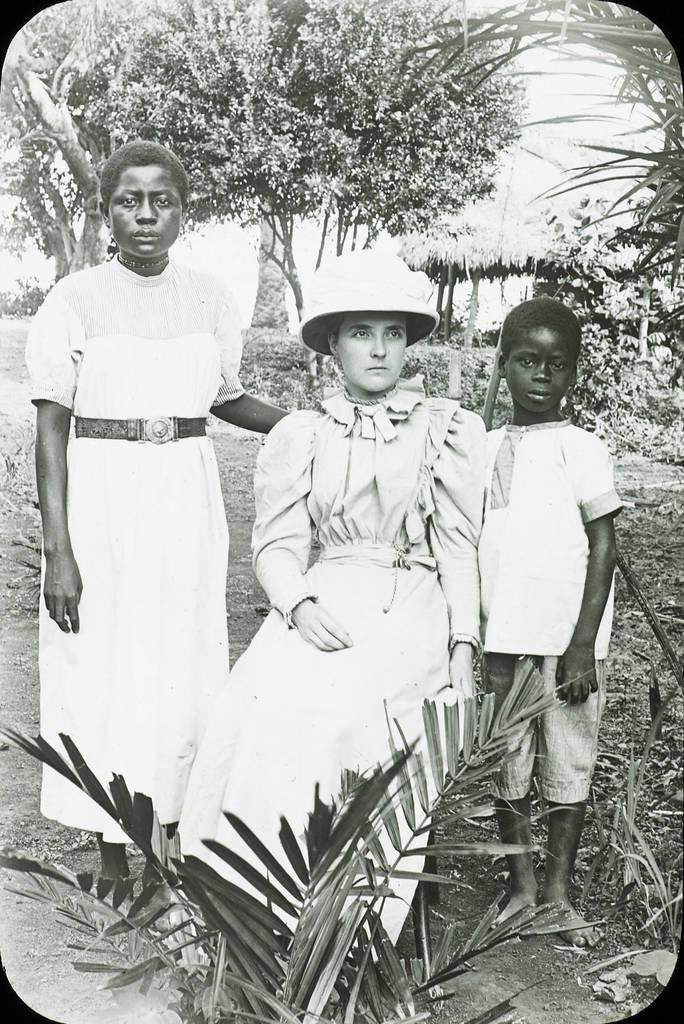How many people are in the image? There are three persons in the image. What is the position of one of the persons? One person is sitting. What can be seen in front of the persons? There are plants in front of the persons. What is visible behind the persons? There are plants, trees, and a hut behind the persons. What type of sponge is being used by the person sitting in the image? There is no sponge visible in the image, and no indication that a sponge is being used by any of the persons. 